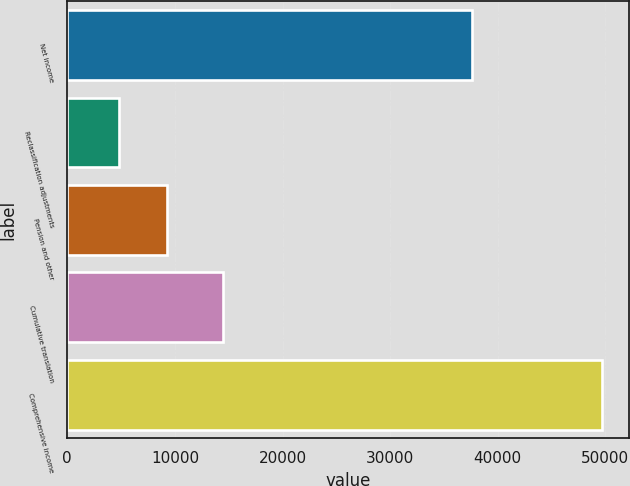<chart> <loc_0><loc_0><loc_500><loc_500><bar_chart><fcel>Net income<fcel>Reclassification adjustments<fcel>Pension and other<fcel>Cumulative translation<fcel>Comprehensive income<nl><fcel>37630<fcel>4780<fcel>9271.6<fcel>14445<fcel>49696<nl></chart> 